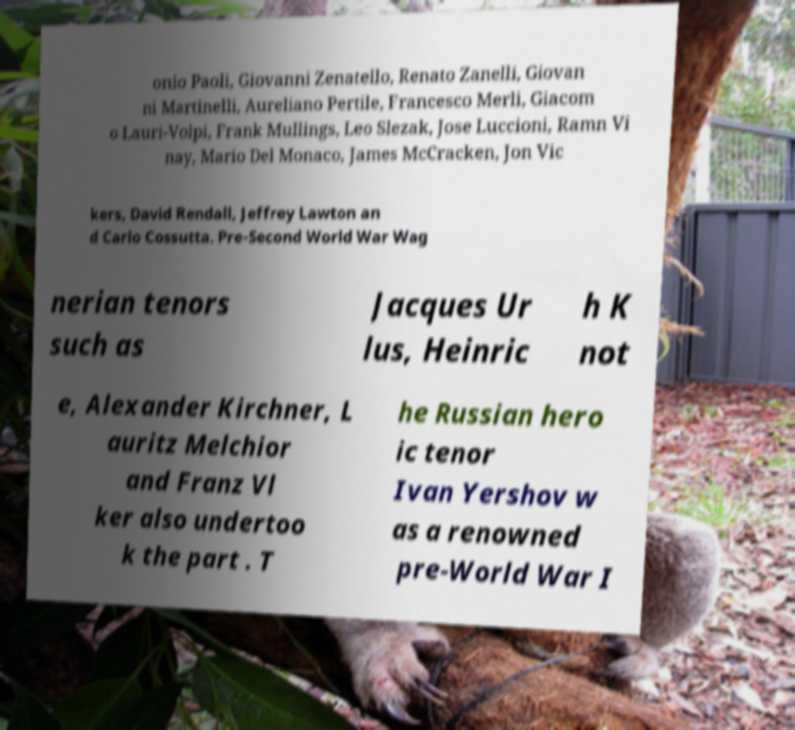What messages or text are displayed in this image? I need them in a readable, typed format. onio Paoli, Giovanni Zenatello, Renato Zanelli, Giovan ni Martinelli, Aureliano Pertile, Francesco Merli, Giacom o Lauri-Volpi, Frank Mullings, Leo Slezak, Jose Luccioni, Ramn Vi nay, Mario Del Monaco, James McCracken, Jon Vic kers, David Rendall, Jeffrey Lawton an d Carlo Cossutta. Pre-Second World War Wag nerian tenors such as Jacques Ur lus, Heinric h K not e, Alexander Kirchner, L auritz Melchior and Franz Vl ker also undertoo k the part . T he Russian hero ic tenor Ivan Yershov w as a renowned pre-World War I 